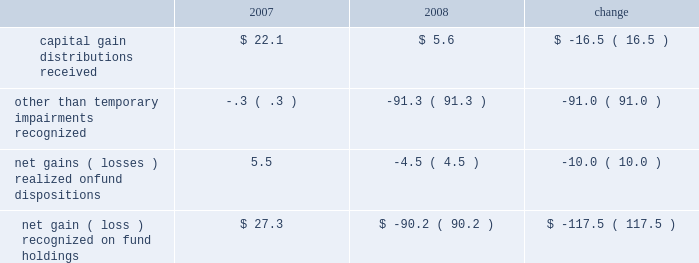Administrative fees , which increased $ 5.8 million to $ 353.9 million , are generally offset by related operating expenses that are incurred to provide services to the funds and their investors .
Our largest expense , compensation and related costs , increased $ 18.4 million or 2.3% ( 2.3 % ) from 2007 .
This increase includes $ 37.2 million in salaries resulting from an 8.4% ( 8.4 % ) increase in our average staff count and an increase of our associates 2019 base salaries at the beginning of the year .
At december 31 , 2008 , we employed 5385 associates , up 6.0% ( 6.0 % ) from the end of 2007 , primarily to add capabilities and support increased volume-related activities and other growth over the past few years .
Over the course of 2008 , we slowed the growth of our associate base from earlier plans and the prior year .
We also reduced our annual bonuses $ 27.6 million versus the 2007 year in response to unfavorable financial market conditions that negatively impacted our operating results .
The balance of the increase is attributable to higher employee benefits and employment-related expenses , including an increase of $ 5.7 million in stock-based compensation .
After higher spending during the first quarter of 2008 versus 2007 , investor sentiment in the uncertain and volatile market environment caused us to reduce advertising and promotion spending , which for the year was down $ 3.8 million from 2007 .
Occupancy and facility costs together with depreciation expense increased $ 18 million , or 12% ( 12 % ) compared to 2007 .
We expanded and renovated our facilities in 2008 to accommodate the growth in our associates to meet business demands .
Other operating expenses were up $ 3.3 million from 2007 .
We increased our spending $ 9.8 million , primarily for professional fees and information and other third-party services .
Reductions in travel and charitable contributions partially offset these increases .
Our non-operating investment activity resulted in a net loss of $ 52.3 million in 2008 as compared to a net gain of $ 80.4 million in 2007 .
This change of $ 132.7 million is primarily attributable to losses recognized in 2008 on our investments in sponsored mutual funds , which resulted from declines in financial market values during the year. .
We recognized other than temporary impairments of our investments in sponsored mutual funds because of declines in fair value below cost for an extended period .
The significant declines in fair value below cost that occurred in 2008 were generally attributable to adverse market conditions .
In addition , income from money market and bond fund holdings was $ 19.3 million lower than in 2007 due to the significantly lower interest rate environment of 2008 .
Lower interest rates also led to substantial capital appreciation on our $ 40 million holding of u.s .
Treasury notes that we sold in december 2008 at a $ 2.6 million gain .
The 2008 provision for income taxes as a percentage of pretax income is 38.4% ( 38.4 % ) , up from 37.7% ( 37.7 % ) in 2007 , primarily to reflect changes in state income tax rates and regulations and certain adjustments made prospectively based on our annual income tax return filings for 2007 .
C a p i t a l r e s o u r c e s a n d l i q u i d i t y .
During 2009 , stockholders 2019 equity increased from $ 2.5 billion to $ 2.9 billion .
We repurchased nearly 2.3 million common shares for $ 67 million in 2009 .
Tangible book value is $ 2.2 billion at december 31 , 2009 , and our cash and cash equivalents and our mutual fund investment holdings total $ 1.4 billion .
Given the availability of these financial resources , we do not maintain an available external source of liquidity .
On january 20 , 2010 , we purchased a 26% ( 26 % ) equity interest in uti asset management company and an affiliate for $ 142.4 million .
We funded the acquisition from our cash holdings .
In addition to the pending uti acquisition , we had outstanding commitments to fund other investments totaling $ 35.4 million at december 31 , 2009 .
We presently anticipate funding 2010 property and equipment expenditures of about $ 150 million from our cash balances and operating cash inflows .
22 t .
Rowe price group annual report 2009 .
What percentage of tangible book value is made up of cash and cash equivalents and mutual fund investment holdings at december 31 , 2009? 
Rationale: for an investment firm it is expected that the vast majority of tangible book value is liquid .
Computations: (1.4 / 2.2)
Answer: 0.63636. 